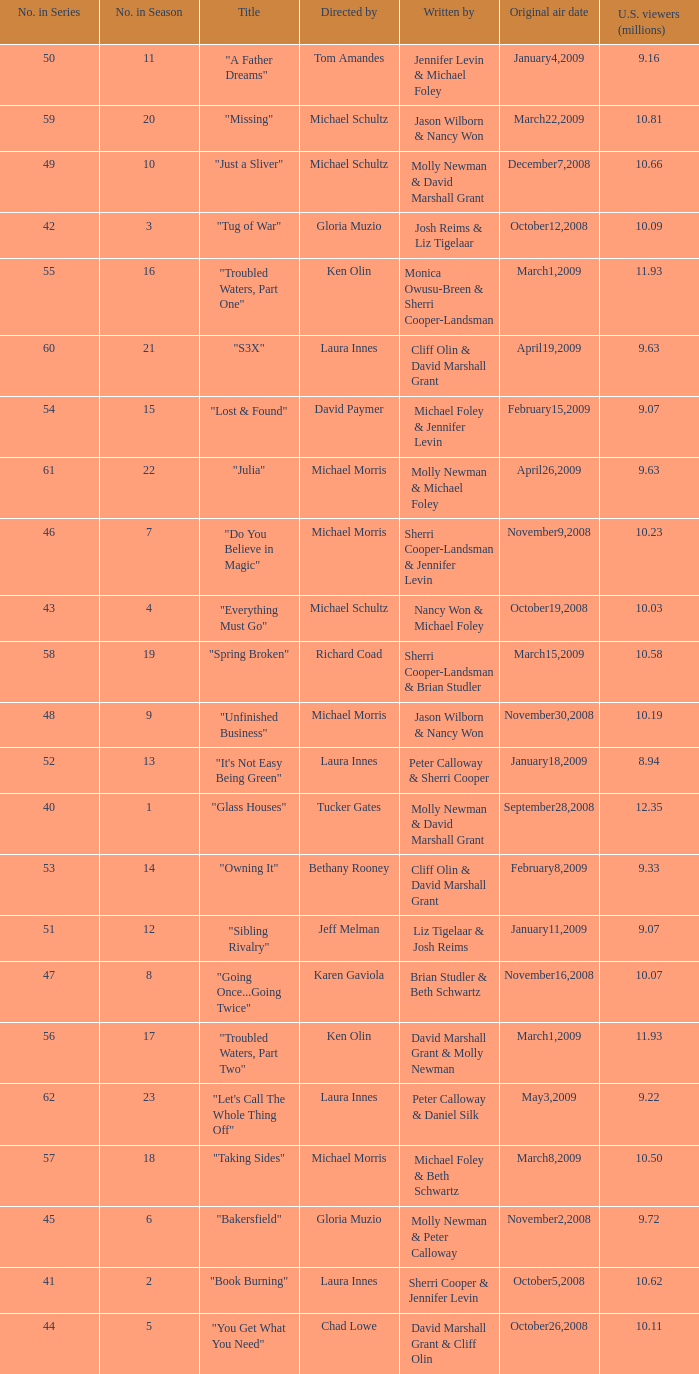When did the episode titled "Do you believe in magic" run for the first time? November9,2008. 